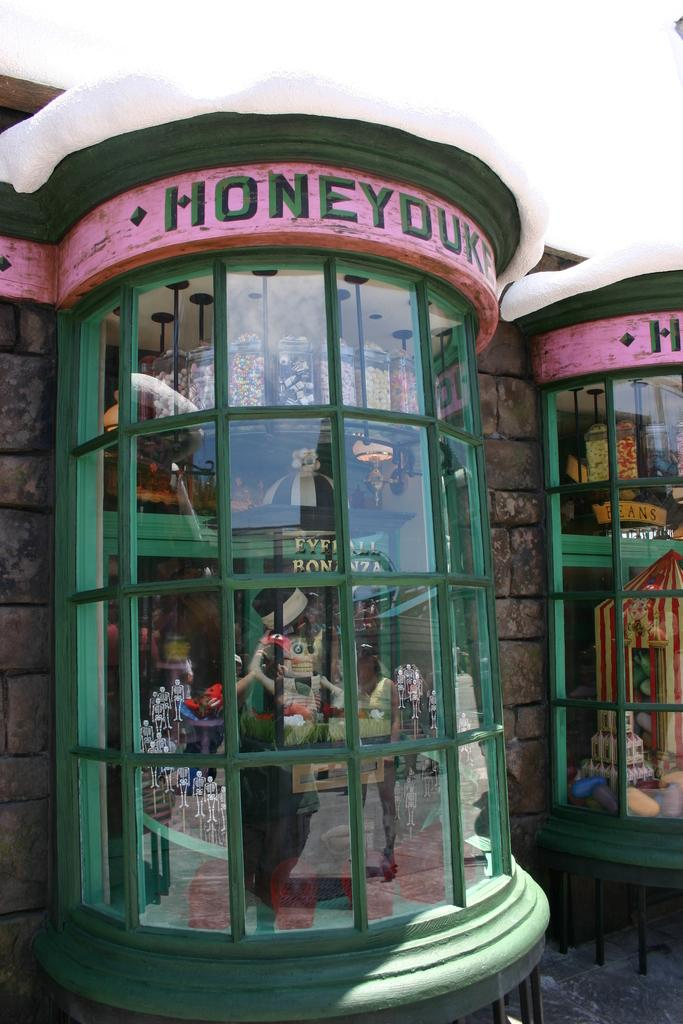How many windows can be seen in the image? There are two windows in the image. What can be seen through one of the windows? A doll is visible through one of the windows. What else can be seen through one of the windows? A group of containers filled with food is visible through one of the windows. What type of chin can be seen on the doll through the window? There is no chin visible on the doll through the window, as the image only shows the doll from a distance and does not provide a close-up view of its features. 